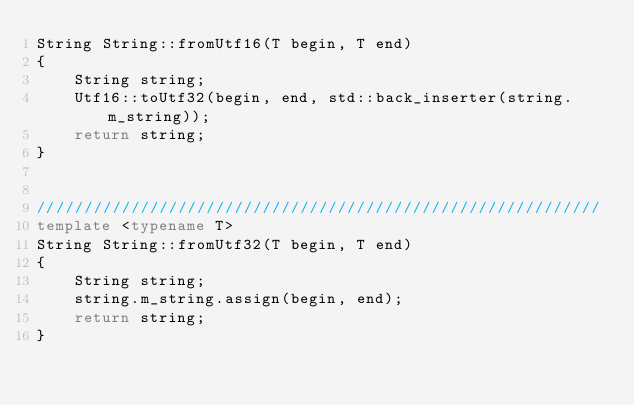<code> <loc_0><loc_0><loc_500><loc_500><_C++_>String String::fromUtf16(T begin, T end)
{
    String string;
    Utf16::toUtf32(begin, end, std::back_inserter(string.m_string));
    return string;
}


////////////////////////////////////////////////////////////
template <typename T>
String String::fromUtf32(T begin, T end)
{
    String string;
    string.m_string.assign(begin, end);
    return string;
}
</code> 